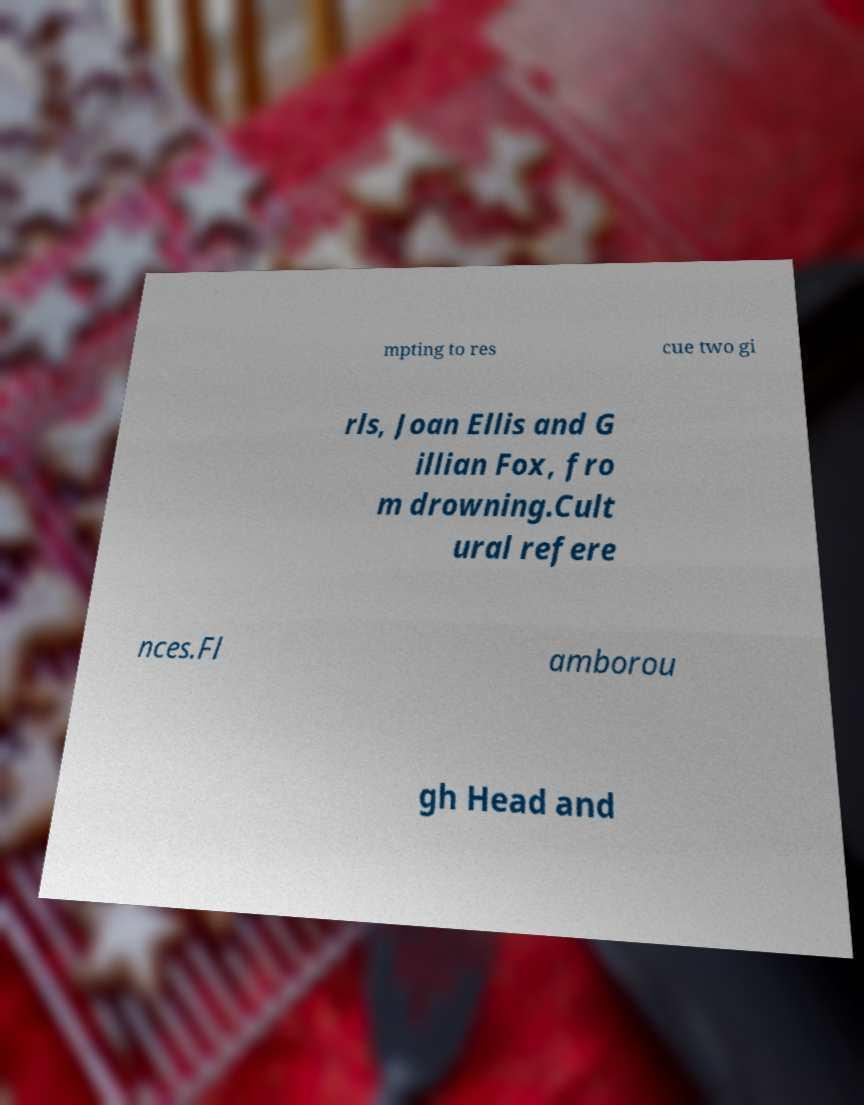Please read and relay the text visible in this image. What does it say? mpting to res cue two gi rls, Joan Ellis and G illian Fox, fro m drowning.Cult ural refere nces.Fl amborou gh Head and 